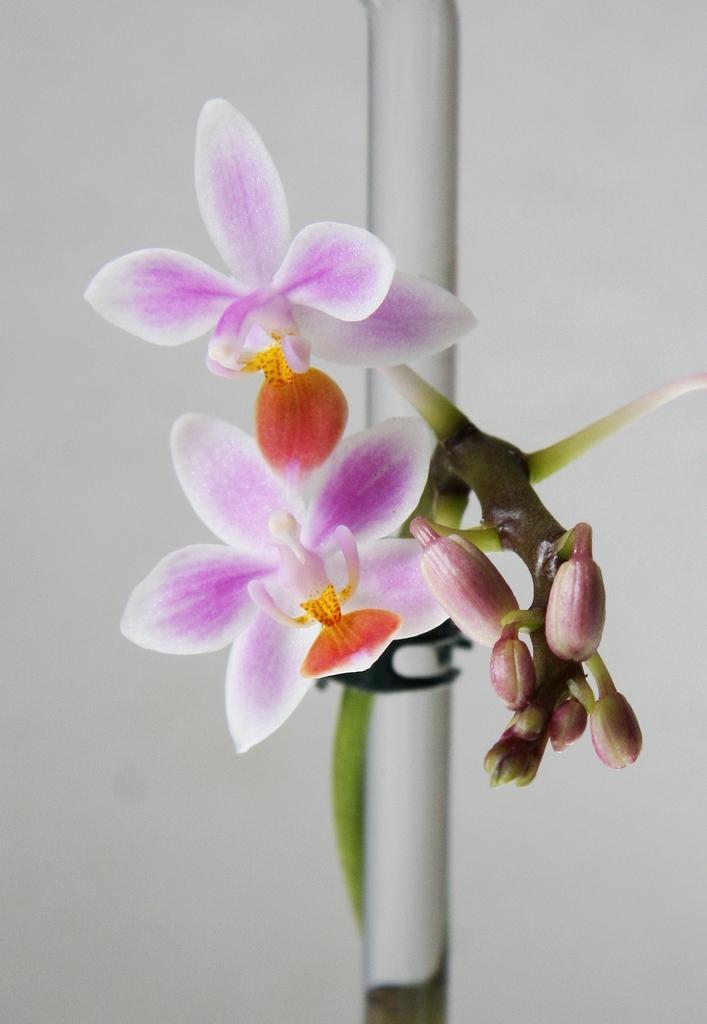In one or two sentences, can you explain what this image depicts? In this image I can see the flowers and the buds. The flowers are in purple, white and orange color. And there is a white background. 